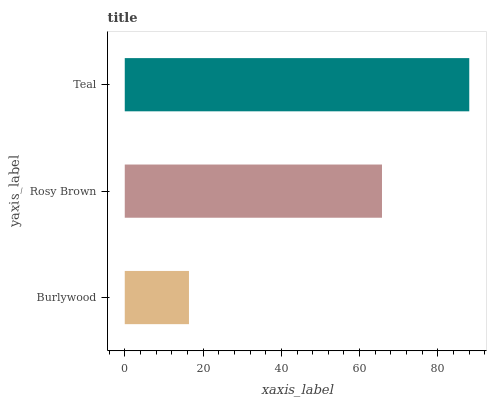Is Burlywood the minimum?
Answer yes or no. Yes. Is Teal the maximum?
Answer yes or no. Yes. Is Rosy Brown the minimum?
Answer yes or no. No. Is Rosy Brown the maximum?
Answer yes or no. No. Is Rosy Brown greater than Burlywood?
Answer yes or no. Yes. Is Burlywood less than Rosy Brown?
Answer yes or no. Yes. Is Burlywood greater than Rosy Brown?
Answer yes or no. No. Is Rosy Brown less than Burlywood?
Answer yes or no. No. Is Rosy Brown the high median?
Answer yes or no. Yes. Is Rosy Brown the low median?
Answer yes or no. Yes. Is Burlywood the high median?
Answer yes or no. No. Is Burlywood the low median?
Answer yes or no. No. 